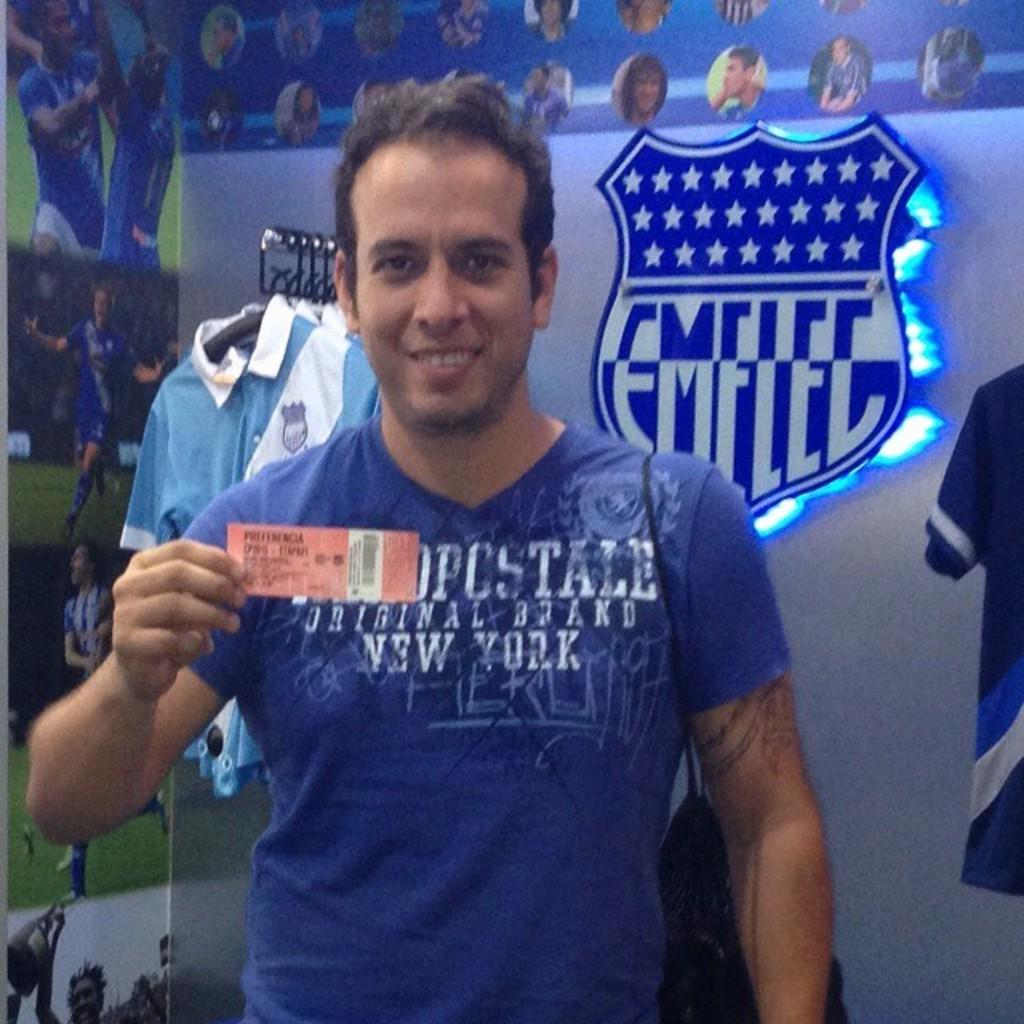<image>
Render a clear and concise summary of the photo. guy wearing blue shirt that has new york on it and emelec logo on wall in background 